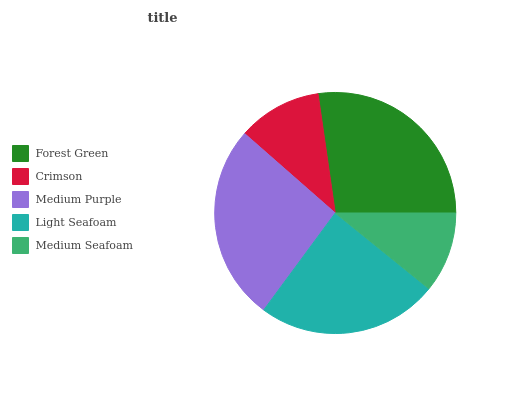Is Medium Seafoam the minimum?
Answer yes or no. Yes. Is Forest Green the maximum?
Answer yes or no. Yes. Is Crimson the minimum?
Answer yes or no. No. Is Crimson the maximum?
Answer yes or no. No. Is Forest Green greater than Crimson?
Answer yes or no. Yes. Is Crimson less than Forest Green?
Answer yes or no. Yes. Is Crimson greater than Forest Green?
Answer yes or no. No. Is Forest Green less than Crimson?
Answer yes or no. No. Is Light Seafoam the high median?
Answer yes or no. Yes. Is Light Seafoam the low median?
Answer yes or no. Yes. Is Crimson the high median?
Answer yes or no. No. Is Crimson the low median?
Answer yes or no. No. 